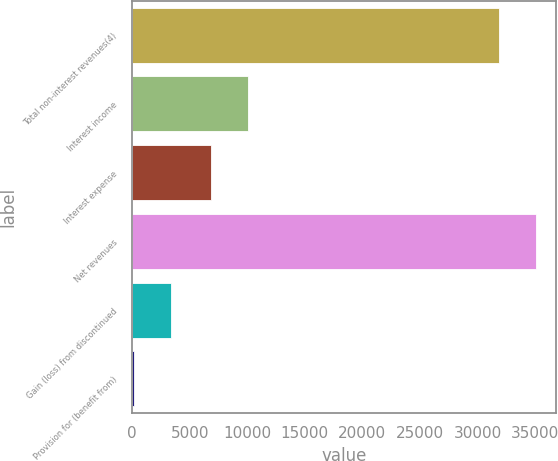Convert chart. <chart><loc_0><loc_0><loc_500><loc_500><bar_chart><fcel>Total non-interest revenues(4)<fcel>Interest income<fcel>Interest expense<fcel>Net revenues<fcel>Gain (loss) from discontinued<fcel>Provision for (benefit from)<nl><fcel>31876<fcel>10093.8<fcel>6883<fcel>35086.8<fcel>3329.8<fcel>119<nl></chart> 